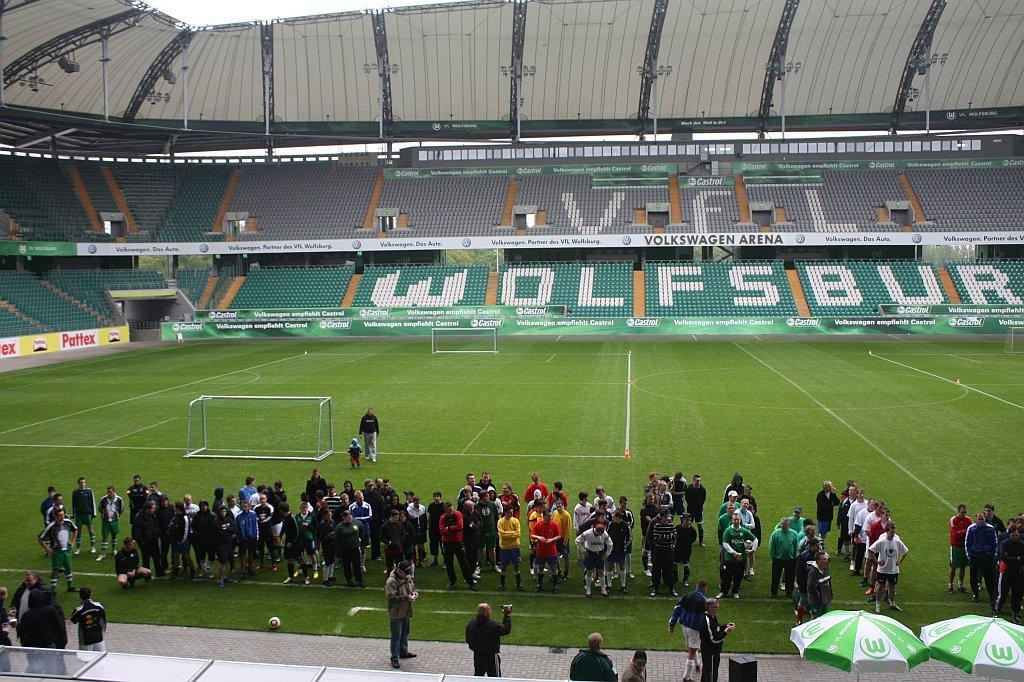What type of location is depicted in the image? The image shows the inside view of a stadium. Are there any people present in the image? Yes, there are people in the image. What else can be seen in the image besides people? There are boards and other objects visible in the image. Is there a water channel visible in the image? No, there is no water channel present in the image. What type of base is supporting the stadium in the image? The image does not show the base of the stadium, so it cannot be determined from the image. 